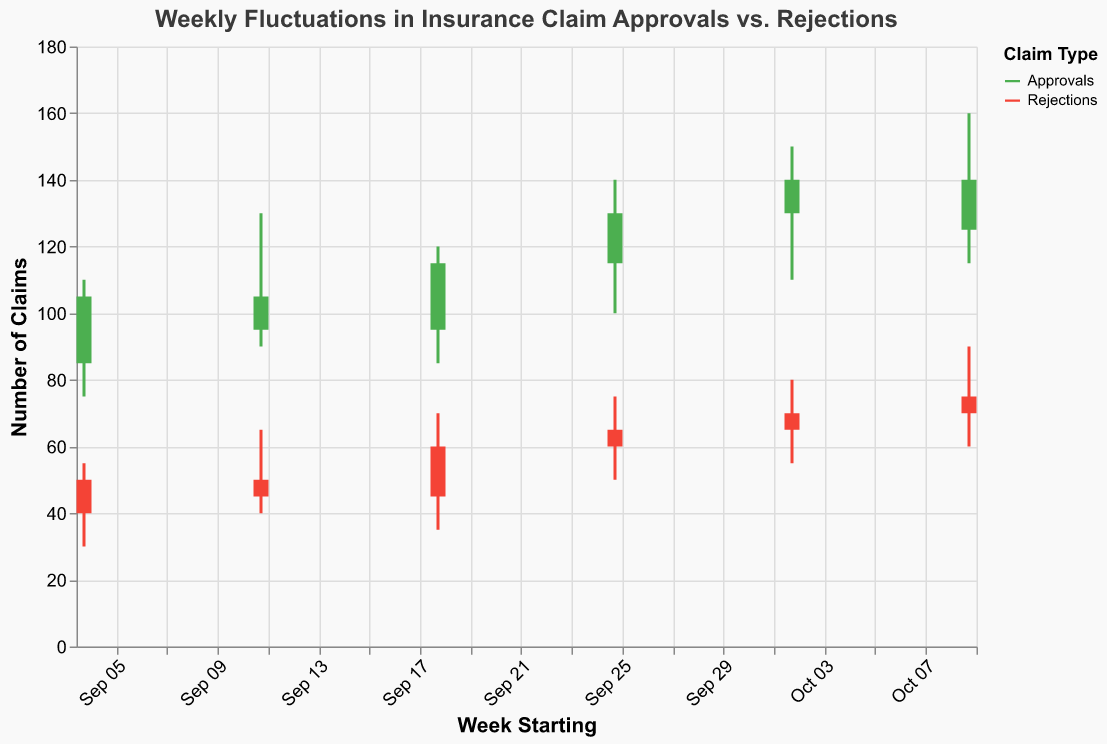What is the title of the figure? The title is displayed at the top of the figure in a larger font, "Weekly Fluctuations in Insurance Claim Approvals vs. Rejections".
Answer: Weekly Fluctuations in Insurance Claim Approvals vs. Rejections How many weeks of data are represented? There are six sets of date values along the x-axis, each starting from a new week.
Answer: Six What colors are used to represent approvals and rejections, respectively? The figure uses green for approvals and red for rejections, based on the color legend.
Answer: Green for approvals, red for rejections Which week had the highest number of approved claims? The high values for approvals are plotted on vertical lines. The week starting October 9 has the highest value of 160.
Answer: Week starting October 9 Which week had the lowest number of rejections? The low values for rejections are plotted on vertical lines. The week starting September 4 has the lowest value of 30.
Answer: Week starting September 4 During the week of September 18, what was the range of approvals? The range is determined by the high and low values for the week. From 120 (high) to 85 (low), the range is 120 - 85.
Answer: 35 How did the number of approved claims change from September 25 to October 2? The closing value of approvals for September 25 and October 2 are compared. September 25 closes at 130, and October 2 closes at 140. The change is 140 - 130.
Answer: Increased by 10 Comparing September 11 and October 2, which week had a lower number of rejected claims closing values? The closing values of rejections for the two weeks are compared. September 11 closes at 45, and October 2 closes at 70.
Answer: September 11 Calculate the average high value of rejections over the six weeks. Add up all the high values (55, 65, 70, 75, 80, 90) and divide by the number of weeks (6). So, (55 + 65 + 70 + 75 + 80 + 90) / 6.
Answer: 72.5 Did the number of approvals demonstrate an overall upward or downward trend? By comparing the opening and closing values over the weeks, we observe that the closing value increases from 105 to 125, indicating an upward trend.
Answer: Upward trend 